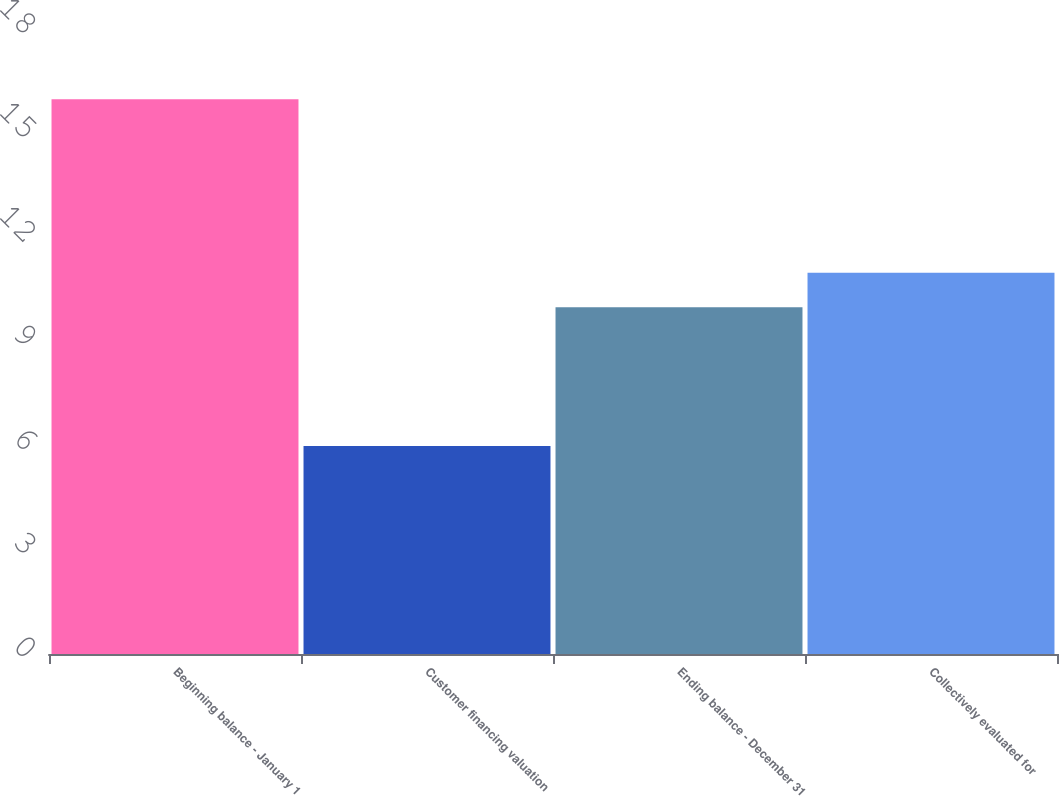Convert chart to OTSL. <chart><loc_0><loc_0><loc_500><loc_500><bar_chart><fcel>Beginning balance - January 1<fcel>Customer financing valuation<fcel>Ending balance - December 31<fcel>Collectively evaluated for<nl><fcel>16<fcel>6<fcel>10<fcel>11<nl></chart> 